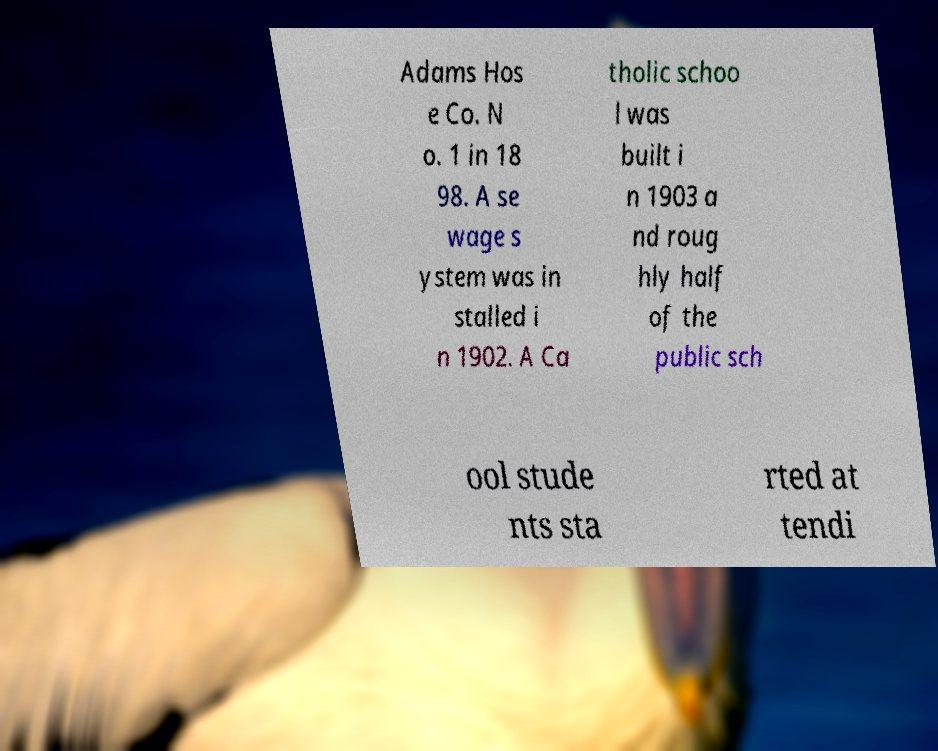Please read and relay the text visible in this image. What does it say? Adams Hos e Co. N o. 1 in 18 98. A se wage s ystem was in stalled i n 1902. A Ca tholic schoo l was built i n 1903 a nd roug hly half of the public sch ool stude nts sta rted at tendi 